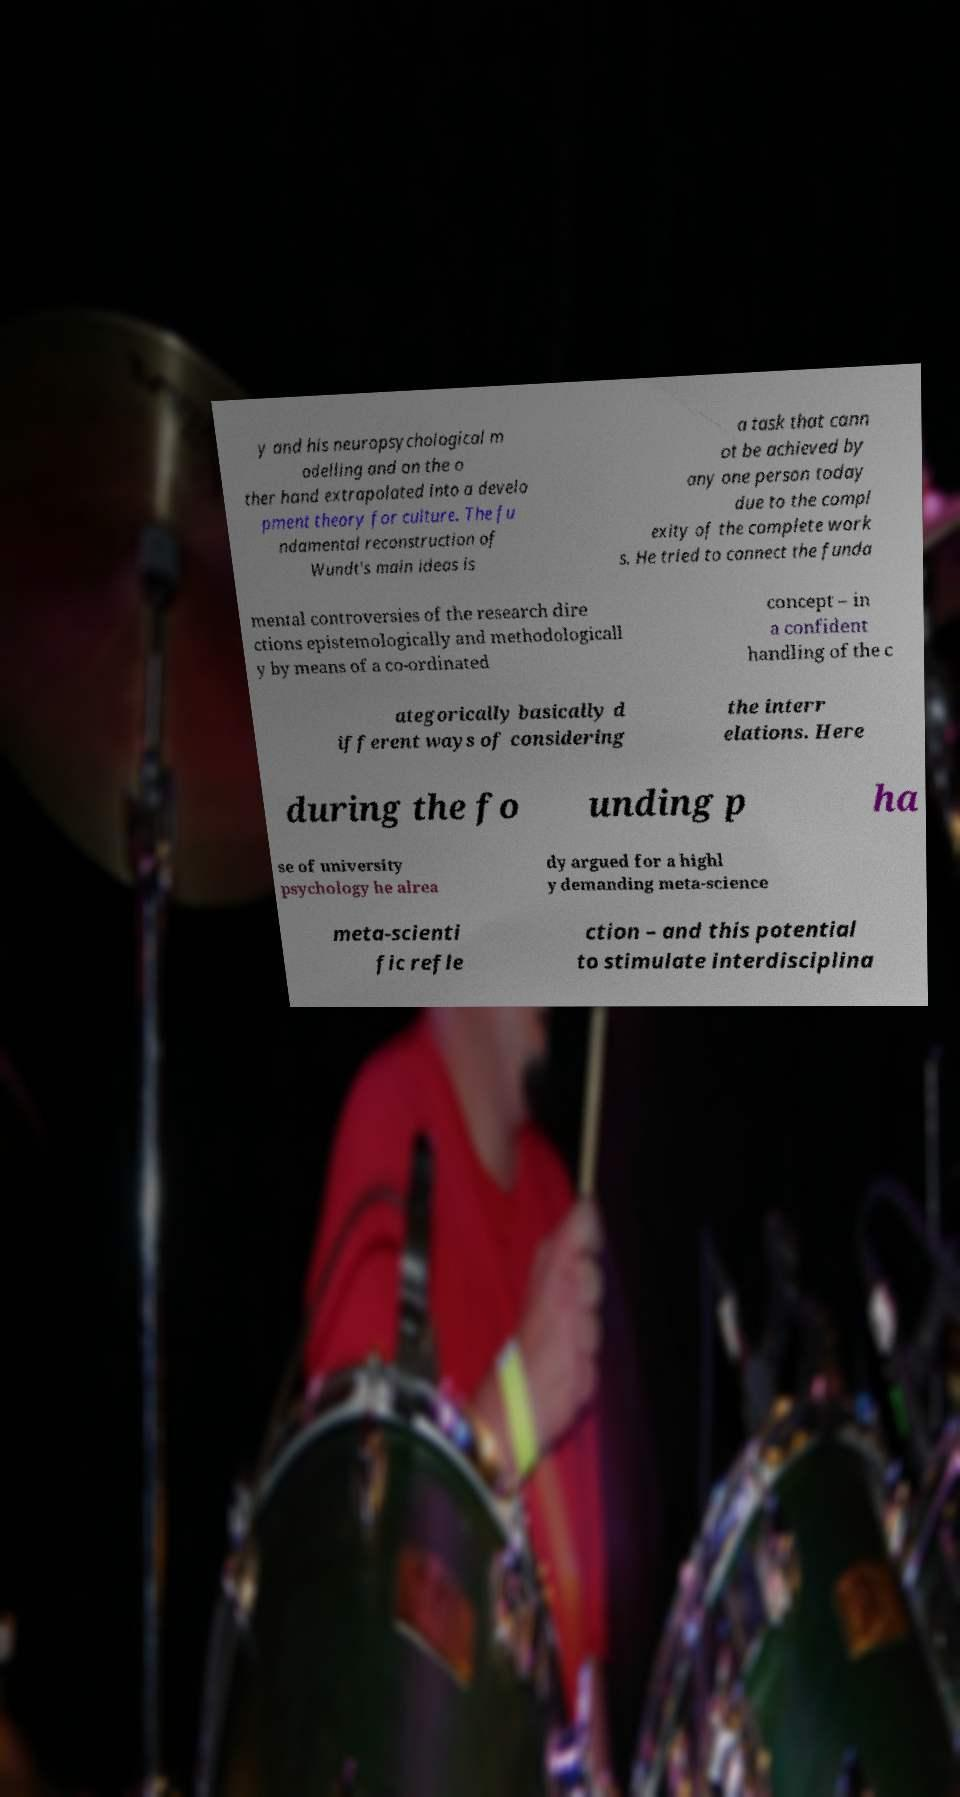Could you extract and type out the text from this image? y and his neuropsychological m odelling and on the o ther hand extrapolated into a develo pment theory for culture. The fu ndamental reconstruction of Wundt's main ideas is a task that cann ot be achieved by any one person today due to the compl exity of the complete work s. He tried to connect the funda mental controversies of the research dire ctions epistemologically and methodologicall y by means of a co-ordinated concept – in a confident handling of the c ategorically basically d ifferent ways of considering the interr elations. Here during the fo unding p ha se of university psychology he alrea dy argued for a highl y demanding meta-science meta-scienti fic refle ction – and this potential to stimulate interdisciplina 